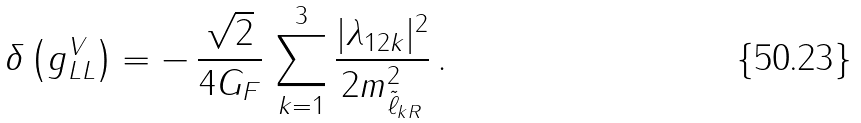<formula> <loc_0><loc_0><loc_500><loc_500>\delta \left ( g _ { L L } ^ { V } \right ) = - \, \frac { \sqrt { 2 } } { 4 G _ { F } } \, \sum _ { k = 1 } ^ { 3 } \frac { | \lambda _ { 1 2 k } | ^ { 2 } } { 2 m _ { \tilde { \ell } _ { k R } } ^ { 2 } } \, .</formula> 